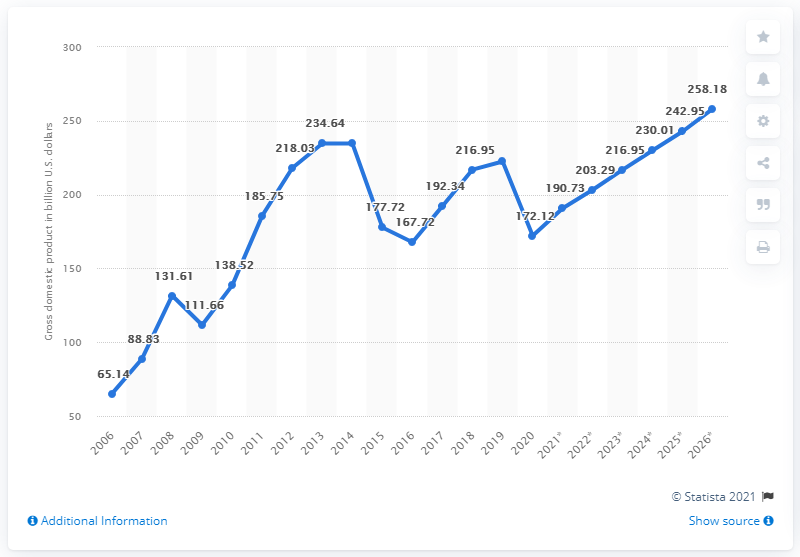Can you describe the trends in Iraq's GDP as shown in the graph? Certainly! The graph indicates a general upward trend in Iraq's GDP over time, with noticeable growth from 2006 until a peak in 2013. Following that, there is a significant drop around 2014 and 2015, then another period of growth until 2019. In 2020, the graph shows a downturn, reflecting the economic impact of events during that year. 